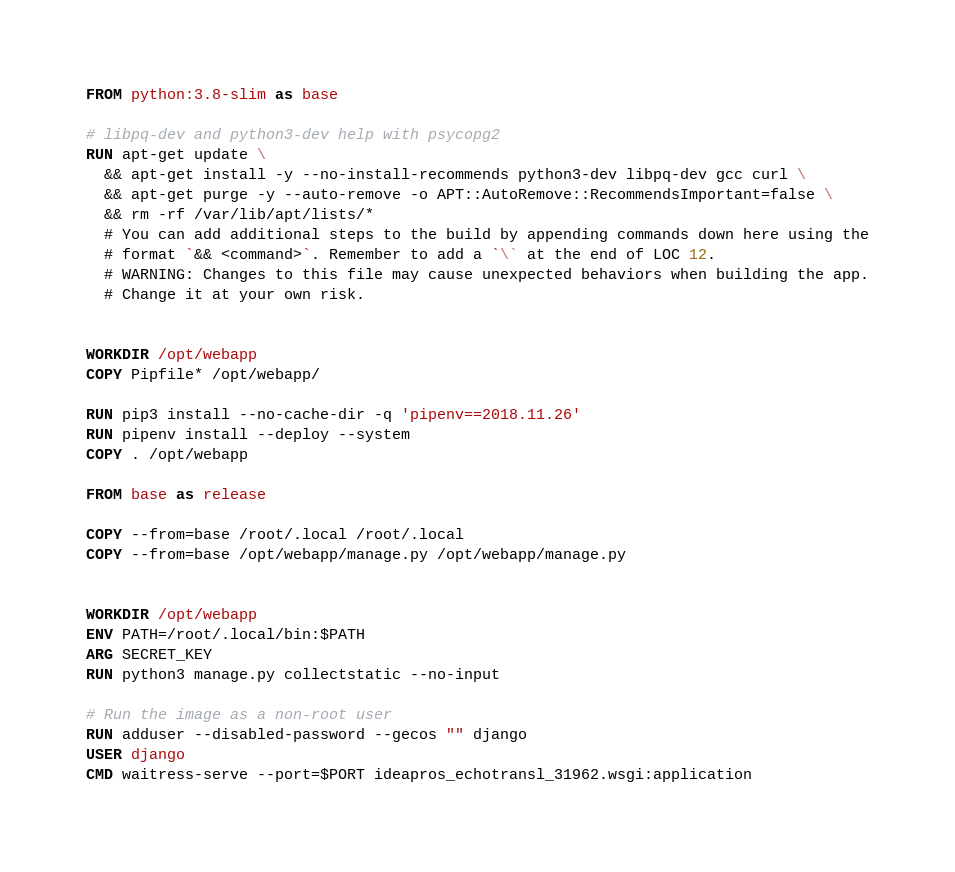Convert code to text. <code><loc_0><loc_0><loc_500><loc_500><_Dockerfile_>FROM python:3.8-slim as base

# libpq-dev and python3-dev help with psycopg2
RUN apt-get update \
  && apt-get install -y --no-install-recommends python3-dev libpq-dev gcc curl \
  && apt-get purge -y --auto-remove -o APT::AutoRemove::RecommendsImportant=false \
  && rm -rf /var/lib/apt/lists/*
  # You can add additional steps to the build by appending commands down here using the
  # format `&& <command>`. Remember to add a `\` at the end of LOC 12.
  # WARNING: Changes to this file may cause unexpected behaviors when building the app.
  # Change it at your own risk.


WORKDIR /opt/webapp
COPY Pipfile* /opt/webapp/

RUN pip3 install --no-cache-dir -q 'pipenv==2018.11.26' 
RUN pipenv install --deploy --system
COPY . /opt/webapp

FROM base as release

COPY --from=base /root/.local /root/.local
COPY --from=base /opt/webapp/manage.py /opt/webapp/manage.py


WORKDIR /opt/webapp
ENV PATH=/root/.local/bin:$PATH
ARG SECRET_KEY 
RUN python3 manage.py collectstatic --no-input

# Run the image as a non-root user
RUN adduser --disabled-password --gecos "" django
USER django
CMD waitress-serve --port=$PORT ideapros_echotransl_31962.wsgi:application
</code> 